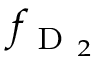<formula> <loc_0><loc_0><loc_500><loc_500>f _ { D _ { 2 } }</formula> 